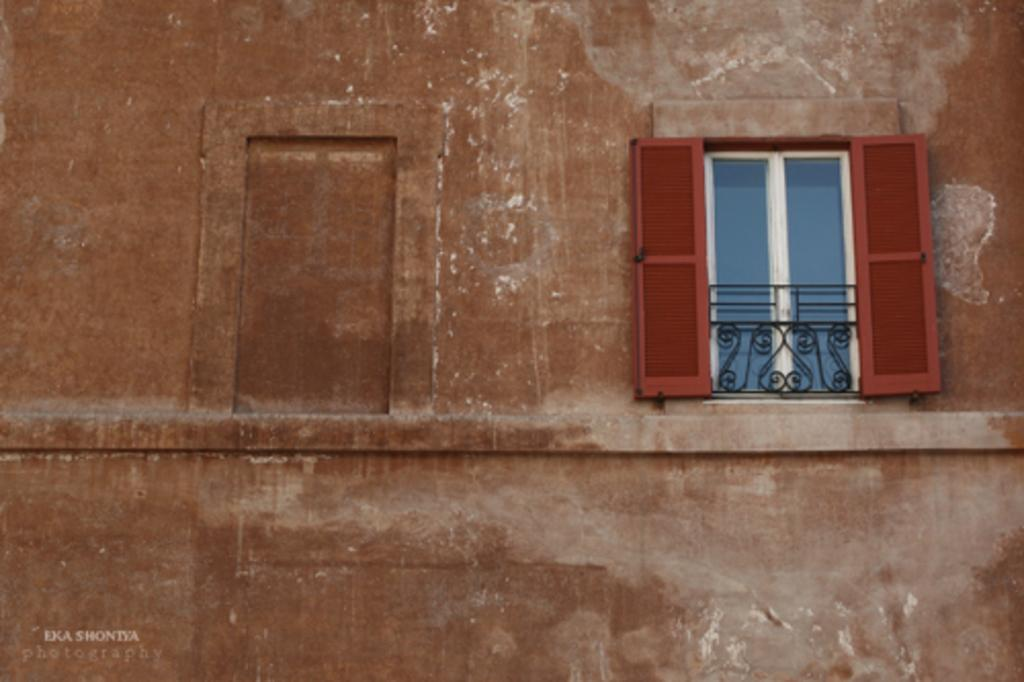What is located at the right side of the image? There is a window at the right side of the image. What feature is associated with the window? The window has a door. What type of barrier is present near the window and door? There is a fence associated with the window and door. What other structure is visible in the image? There is a wall visible in the image. What type of picture is hanging on the wall in the image? There is no picture hanging on the wall in the image. Can you see any rabbits near the fence in the image? There are no rabbits present in the image. 